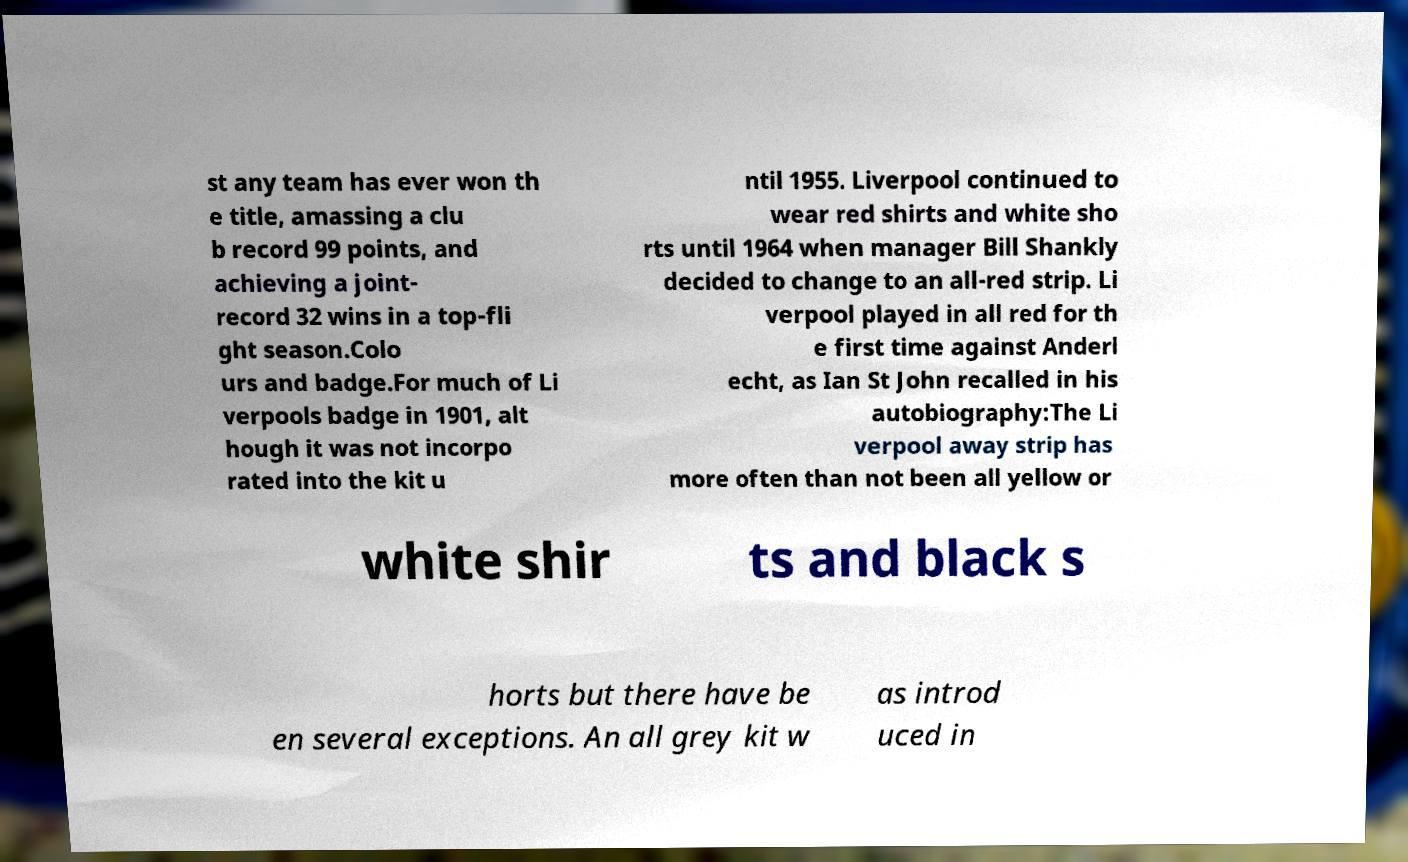Please identify and transcribe the text found in this image. st any team has ever won th e title, amassing a clu b record 99 points, and achieving a joint- record 32 wins in a top-fli ght season.Colo urs and badge.For much of Li verpools badge in 1901, alt hough it was not incorpo rated into the kit u ntil 1955. Liverpool continued to wear red shirts and white sho rts until 1964 when manager Bill Shankly decided to change to an all-red strip. Li verpool played in all red for th e first time against Anderl echt, as Ian St John recalled in his autobiography:The Li verpool away strip has more often than not been all yellow or white shir ts and black s horts but there have be en several exceptions. An all grey kit w as introd uced in 